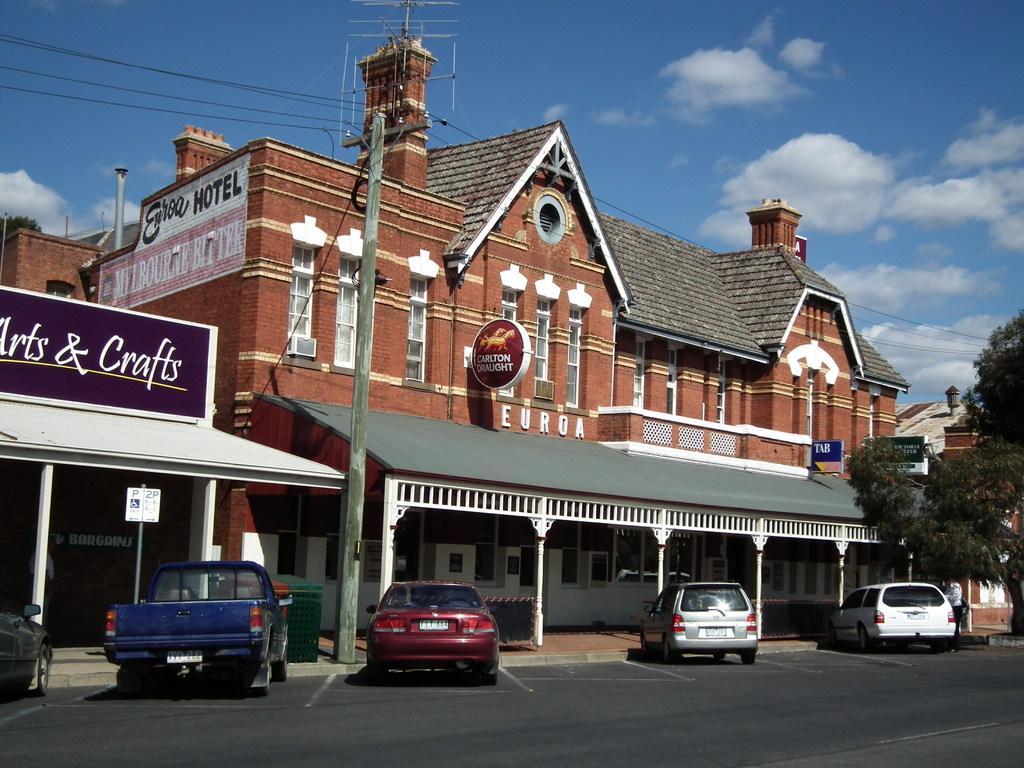Describe this image in one or two sentences. I the picture I can see buildings, boards, trees, few vehicles are parked beside the road and clouded sky. 